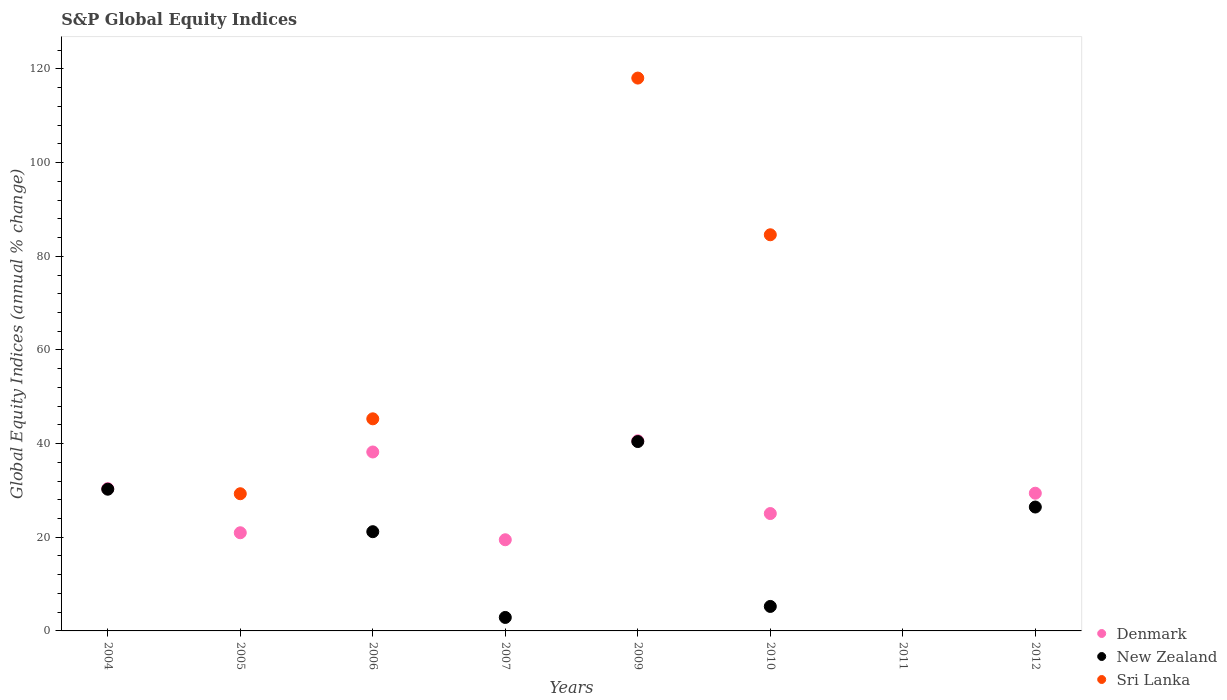How many different coloured dotlines are there?
Make the answer very short. 3. Is the number of dotlines equal to the number of legend labels?
Make the answer very short. No. What is the global equity indices in Sri Lanka in 2007?
Make the answer very short. 0. Across all years, what is the maximum global equity indices in Sri Lanka?
Provide a short and direct response. 118.05. Across all years, what is the minimum global equity indices in Sri Lanka?
Give a very brief answer. 0. What is the total global equity indices in Sri Lanka in the graph?
Provide a succinct answer. 277.22. What is the difference between the global equity indices in New Zealand in 2004 and that in 2010?
Make the answer very short. 25.03. What is the difference between the global equity indices in Sri Lanka in 2006 and the global equity indices in New Zealand in 2010?
Make the answer very short. 40.06. What is the average global equity indices in Denmark per year?
Ensure brevity in your answer.  25.51. In the year 2006, what is the difference between the global equity indices in Denmark and global equity indices in Sri Lanka?
Make the answer very short. -7.08. What is the ratio of the global equity indices in New Zealand in 2009 to that in 2010?
Your answer should be compact. 7.73. Is the global equity indices in New Zealand in 2004 less than that in 2012?
Provide a succinct answer. No. What is the difference between the highest and the second highest global equity indices in Denmark?
Your response must be concise. 2.39. What is the difference between the highest and the lowest global equity indices in Sri Lanka?
Offer a very short reply. 118.05. How many dotlines are there?
Keep it short and to the point. 3. How many years are there in the graph?
Keep it short and to the point. 8. What is the difference between two consecutive major ticks on the Y-axis?
Provide a short and direct response. 20. Are the values on the major ticks of Y-axis written in scientific E-notation?
Your response must be concise. No. Does the graph contain any zero values?
Your response must be concise. Yes. Does the graph contain grids?
Give a very brief answer. No. Where does the legend appear in the graph?
Your answer should be compact. Bottom right. What is the title of the graph?
Your answer should be compact. S&P Global Equity Indices. Does "Greece" appear as one of the legend labels in the graph?
Your answer should be very brief. No. What is the label or title of the Y-axis?
Offer a terse response. Global Equity Indices (annual % change). What is the Global Equity Indices (annual % change) of Denmark in 2004?
Ensure brevity in your answer.  30.39. What is the Global Equity Indices (annual % change) in New Zealand in 2004?
Ensure brevity in your answer.  30.26. What is the Global Equity Indices (annual % change) of Denmark in 2005?
Keep it short and to the point. 20.96. What is the Global Equity Indices (annual % change) in Sri Lanka in 2005?
Your answer should be very brief. 29.29. What is the Global Equity Indices (annual % change) in Denmark in 2006?
Offer a terse response. 38.21. What is the Global Equity Indices (annual % change) of New Zealand in 2006?
Provide a succinct answer. 21.19. What is the Global Equity Indices (annual % change) of Sri Lanka in 2006?
Your answer should be compact. 45.29. What is the Global Equity Indices (annual % change) in Denmark in 2007?
Ensure brevity in your answer.  19.47. What is the Global Equity Indices (annual % change) in New Zealand in 2007?
Provide a short and direct response. 2.88. What is the Global Equity Indices (annual % change) of Denmark in 2009?
Give a very brief answer. 40.6. What is the Global Equity Indices (annual % change) of New Zealand in 2009?
Ensure brevity in your answer.  40.44. What is the Global Equity Indices (annual % change) in Sri Lanka in 2009?
Your answer should be compact. 118.05. What is the Global Equity Indices (annual % change) of Denmark in 2010?
Your response must be concise. 25.06. What is the Global Equity Indices (annual % change) of New Zealand in 2010?
Give a very brief answer. 5.23. What is the Global Equity Indices (annual % change) in Sri Lanka in 2010?
Provide a succinct answer. 84.59. What is the Global Equity Indices (annual % change) in Denmark in 2011?
Offer a very short reply. 0. What is the Global Equity Indices (annual % change) of Denmark in 2012?
Provide a succinct answer. 29.4. What is the Global Equity Indices (annual % change) in New Zealand in 2012?
Offer a terse response. 26.46. Across all years, what is the maximum Global Equity Indices (annual % change) of Denmark?
Ensure brevity in your answer.  40.6. Across all years, what is the maximum Global Equity Indices (annual % change) of New Zealand?
Keep it short and to the point. 40.44. Across all years, what is the maximum Global Equity Indices (annual % change) in Sri Lanka?
Keep it short and to the point. 118.05. Across all years, what is the minimum Global Equity Indices (annual % change) in Denmark?
Your response must be concise. 0. Across all years, what is the minimum Global Equity Indices (annual % change) of Sri Lanka?
Keep it short and to the point. 0. What is the total Global Equity Indices (annual % change) in Denmark in the graph?
Offer a terse response. 204.1. What is the total Global Equity Indices (annual % change) of New Zealand in the graph?
Offer a very short reply. 126.45. What is the total Global Equity Indices (annual % change) of Sri Lanka in the graph?
Keep it short and to the point. 277.23. What is the difference between the Global Equity Indices (annual % change) in Denmark in 2004 and that in 2005?
Offer a very short reply. 9.43. What is the difference between the Global Equity Indices (annual % change) of Denmark in 2004 and that in 2006?
Your answer should be compact. -7.82. What is the difference between the Global Equity Indices (annual % change) of New Zealand in 2004 and that in 2006?
Your response must be concise. 9.07. What is the difference between the Global Equity Indices (annual % change) in Denmark in 2004 and that in 2007?
Offer a terse response. 10.92. What is the difference between the Global Equity Indices (annual % change) of New Zealand in 2004 and that in 2007?
Give a very brief answer. 27.38. What is the difference between the Global Equity Indices (annual % change) of Denmark in 2004 and that in 2009?
Keep it short and to the point. -10.21. What is the difference between the Global Equity Indices (annual % change) in New Zealand in 2004 and that in 2009?
Provide a short and direct response. -10.18. What is the difference between the Global Equity Indices (annual % change) in Denmark in 2004 and that in 2010?
Your answer should be very brief. 5.33. What is the difference between the Global Equity Indices (annual % change) in New Zealand in 2004 and that in 2010?
Your answer should be compact. 25.03. What is the difference between the Global Equity Indices (annual % change) in Denmark in 2004 and that in 2012?
Your response must be concise. 0.99. What is the difference between the Global Equity Indices (annual % change) of New Zealand in 2004 and that in 2012?
Keep it short and to the point. 3.81. What is the difference between the Global Equity Indices (annual % change) in Denmark in 2005 and that in 2006?
Your answer should be very brief. -17.25. What is the difference between the Global Equity Indices (annual % change) of Sri Lanka in 2005 and that in 2006?
Make the answer very short. -16. What is the difference between the Global Equity Indices (annual % change) in Denmark in 2005 and that in 2007?
Keep it short and to the point. 1.5. What is the difference between the Global Equity Indices (annual % change) of Denmark in 2005 and that in 2009?
Offer a terse response. -19.64. What is the difference between the Global Equity Indices (annual % change) in Sri Lanka in 2005 and that in 2009?
Offer a very short reply. -88.76. What is the difference between the Global Equity Indices (annual % change) in Denmark in 2005 and that in 2010?
Offer a very short reply. -4.1. What is the difference between the Global Equity Indices (annual % change) of Sri Lanka in 2005 and that in 2010?
Offer a terse response. -55.3. What is the difference between the Global Equity Indices (annual % change) of Denmark in 2005 and that in 2012?
Give a very brief answer. -8.44. What is the difference between the Global Equity Indices (annual % change) in Denmark in 2006 and that in 2007?
Provide a short and direct response. 18.74. What is the difference between the Global Equity Indices (annual % change) of New Zealand in 2006 and that in 2007?
Offer a very short reply. 18.31. What is the difference between the Global Equity Indices (annual % change) in Denmark in 2006 and that in 2009?
Make the answer very short. -2.39. What is the difference between the Global Equity Indices (annual % change) in New Zealand in 2006 and that in 2009?
Provide a short and direct response. -19.25. What is the difference between the Global Equity Indices (annual % change) of Sri Lanka in 2006 and that in 2009?
Your answer should be compact. -72.76. What is the difference between the Global Equity Indices (annual % change) of Denmark in 2006 and that in 2010?
Offer a terse response. 13.15. What is the difference between the Global Equity Indices (annual % change) of New Zealand in 2006 and that in 2010?
Offer a terse response. 15.96. What is the difference between the Global Equity Indices (annual % change) of Sri Lanka in 2006 and that in 2010?
Keep it short and to the point. -39.3. What is the difference between the Global Equity Indices (annual % change) in Denmark in 2006 and that in 2012?
Ensure brevity in your answer.  8.8. What is the difference between the Global Equity Indices (annual % change) in New Zealand in 2006 and that in 2012?
Your answer should be very brief. -5.27. What is the difference between the Global Equity Indices (annual % change) in Denmark in 2007 and that in 2009?
Ensure brevity in your answer.  -21.14. What is the difference between the Global Equity Indices (annual % change) of New Zealand in 2007 and that in 2009?
Make the answer very short. -37.56. What is the difference between the Global Equity Indices (annual % change) of Denmark in 2007 and that in 2010?
Your answer should be very brief. -5.6. What is the difference between the Global Equity Indices (annual % change) in New Zealand in 2007 and that in 2010?
Ensure brevity in your answer.  -2.35. What is the difference between the Global Equity Indices (annual % change) in Denmark in 2007 and that in 2012?
Provide a short and direct response. -9.94. What is the difference between the Global Equity Indices (annual % change) in New Zealand in 2007 and that in 2012?
Your response must be concise. -23.58. What is the difference between the Global Equity Indices (annual % change) in Denmark in 2009 and that in 2010?
Provide a short and direct response. 15.54. What is the difference between the Global Equity Indices (annual % change) in New Zealand in 2009 and that in 2010?
Provide a succinct answer. 35.21. What is the difference between the Global Equity Indices (annual % change) of Sri Lanka in 2009 and that in 2010?
Make the answer very short. 33.46. What is the difference between the Global Equity Indices (annual % change) in Denmark in 2009 and that in 2012?
Make the answer very short. 11.2. What is the difference between the Global Equity Indices (annual % change) of New Zealand in 2009 and that in 2012?
Keep it short and to the point. 13.98. What is the difference between the Global Equity Indices (annual % change) of Denmark in 2010 and that in 2012?
Offer a terse response. -4.34. What is the difference between the Global Equity Indices (annual % change) of New Zealand in 2010 and that in 2012?
Offer a very short reply. -21.23. What is the difference between the Global Equity Indices (annual % change) of Denmark in 2004 and the Global Equity Indices (annual % change) of Sri Lanka in 2005?
Offer a very short reply. 1.1. What is the difference between the Global Equity Indices (annual % change) in New Zealand in 2004 and the Global Equity Indices (annual % change) in Sri Lanka in 2005?
Your answer should be compact. 0.97. What is the difference between the Global Equity Indices (annual % change) of Denmark in 2004 and the Global Equity Indices (annual % change) of New Zealand in 2006?
Offer a very short reply. 9.2. What is the difference between the Global Equity Indices (annual % change) in Denmark in 2004 and the Global Equity Indices (annual % change) in Sri Lanka in 2006?
Make the answer very short. -14.9. What is the difference between the Global Equity Indices (annual % change) in New Zealand in 2004 and the Global Equity Indices (annual % change) in Sri Lanka in 2006?
Provide a succinct answer. -15.03. What is the difference between the Global Equity Indices (annual % change) of Denmark in 2004 and the Global Equity Indices (annual % change) of New Zealand in 2007?
Provide a short and direct response. 27.51. What is the difference between the Global Equity Indices (annual % change) of Denmark in 2004 and the Global Equity Indices (annual % change) of New Zealand in 2009?
Your response must be concise. -10.05. What is the difference between the Global Equity Indices (annual % change) in Denmark in 2004 and the Global Equity Indices (annual % change) in Sri Lanka in 2009?
Offer a very short reply. -87.66. What is the difference between the Global Equity Indices (annual % change) of New Zealand in 2004 and the Global Equity Indices (annual % change) of Sri Lanka in 2009?
Your response must be concise. -87.79. What is the difference between the Global Equity Indices (annual % change) of Denmark in 2004 and the Global Equity Indices (annual % change) of New Zealand in 2010?
Your answer should be very brief. 25.16. What is the difference between the Global Equity Indices (annual % change) of Denmark in 2004 and the Global Equity Indices (annual % change) of Sri Lanka in 2010?
Give a very brief answer. -54.2. What is the difference between the Global Equity Indices (annual % change) of New Zealand in 2004 and the Global Equity Indices (annual % change) of Sri Lanka in 2010?
Your answer should be compact. -54.33. What is the difference between the Global Equity Indices (annual % change) of Denmark in 2004 and the Global Equity Indices (annual % change) of New Zealand in 2012?
Your answer should be very brief. 3.93. What is the difference between the Global Equity Indices (annual % change) of Denmark in 2005 and the Global Equity Indices (annual % change) of New Zealand in 2006?
Your answer should be very brief. -0.23. What is the difference between the Global Equity Indices (annual % change) in Denmark in 2005 and the Global Equity Indices (annual % change) in Sri Lanka in 2006?
Ensure brevity in your answer.  -24.33. What is the difference between the Global Equity Indices (annual % change) in Denmark in 2005 and the Global Equity Indices (annual % change) in New Zealand in 2007?
Your response must be concise. 18.08. What is the difference between the Global Equity Indices (annual % change) of Denmark in 2005 and the Global Equity Indices (annual % change) of New Zealand in 2009?
Offer a very short reply. -19.47. What is the difference between the Global Equity Indices (annual % change) in Denmark in 2005 and the Global Equity Indices (annual % change) in Sri Lanka in 2009?
Offer a terse response. -97.09. What is the difference between the Global Equity Indices (annual % change) in Denmark in 2005 and the Global Equity Indices (annual % change) in New Zealand in 2010?
Offer a terse response. 15.73. What is the difference between the Global Equity Indices (annual % change) in Denmark in 2005 and the Global Equity Indices (annual % change) in Sri Lanka in 2010?
Provide a short and direct response. -63.63. What is the difference between the Global Equity Indices (annual % change) in Denmark in 2005 and the Global Equity Indices (annual % change) in New Zealand in 2012?
Your response must be concise. -5.49. What is the difference between the Global Equity Indices (annual % change) in Denmark in 2006 and the Global Equity Indices (annual % change) in New Zealand in 2007?
Your answer should be compact. 35.33. What is the difference between the Global Equity Indices (annual % change) of Denmark in 2006 and the Global Equity Indices (annual % change) of New Zealand in 2009?
Your response must be concise. -2.23. What is the difference between the Global Equity Indices (annual % change) of Denmark in 2006 and the Global Equity Indices (annual % change) of Sri Lanka in 2009?
Provide a succinct answer. -79.84. What is the difference between the Global Equity Indices (annual % change) of New Zealand in 2006 and the Global Equity Indices (annual % change) of Sri Lanka in 2009?
Offer a terse response. -96.86. What is the difference between the Global Equity Indices (annual % change) in Denmark in 2006 and the Global Equity Indices (annual % change) in New Zealand in 2010?
Your response must be concise. 32.98. What is the difference between the Global Equity Indices (annual % change) in Denmark in 2006 and the Global Equity Indices (annual % change) in Sri Lanka in 2010?
Offer a very short reply. -46.38. What is the difference between the Global Equity Indices (annual % change) in New Zealand in 2006 and the Global Equity Indices (annual % change) in Sri Lanka in 2010?
Offer a very short reply. -63.4. What is the difference between the Global Equity Indices (annual % change) of Denmark in 2006 and the Global Equity Indices (annual % change) of New Zealand in 2012?
Provide a short and direct response. 11.75. What is the difference between the Global Equity Indices (annual % change) of Denmark in 2007 and the Global Equity Indices (annual % change) of New Zealand in 2009?
Keep it short and to the point. -20.97. What is the difference between the Global Equity Indices (annual % change) of Denmark in 2007 and the Global Equity Indices (annual % change) of Sri Lanka in 2009?
Your answer should be very brief. -98.58. What is the difference between the Global Equity Indices (annual % change) in New Zealand in 2007 and the Global Equity Indices (annual % change) in Sri Lanka in 2009?
Offer a terse response. -115.17. What is the difference between the Global Equity Indices (annual % change) in Denmark in 2007 and the Global Equity Indices (annual % change) in New Zealand in 2010?
Your answer should be very brief. 14.24. What is the difference between the Global Equity Indices (annual % change) of Denmark in 2007 and the Global Equity Indices (annual % change) of Sri Lanka in 2010?
Your answer should be very brief. -65.12. What is the difference between the Global Equity Indices (annual % change) in New Zealand in 2007 and the Global Equity Indices (annual % change) in Sri Lanka in 2010?
Your answer should be very brief. -81.71. What is the difference between the Global Equity Indices (annual % change) in Denmark in 2007 and the Global Equity Indices (annual % change) in New Zealand in 2012?
Give a very brief answer. -6.99. What is the difference between the Global Equity Indices (annual % change) of Denmark in 2009 and the Global Equity Indices (annual % change) of New Zealand in 2010?
Offer a very short reply. 35.37. What is the difference between the Global Equity Indices (annual % change) in Denmark in 2009 and the Global Equity Indices (annual % change) in Sri Lanka in 2010?
Ensure brevity in your answer.  -43.99. What is the difference between the Global Equity Indices (annual % change) of New Zealand in 2009 and the Global Equity Indices (annual % change) of Sri Lanka in 2010?
Keep it short and to the point. -44.15. What is the difference between the Global Equity Indices (annual % change) in Denmark in 2009 and the Global Equity Indices (annual % change) in New Zealand in 2012?
Offer a terse response. 14.15. What is the difference between the Global Equity Indices (annual % change) of Denmark in 2010 and the Global Equity Indices (annual % change) of New Zealand in 2012?
Ensure brevity in your answer.  -1.39. What is the average Global Equity Indices (annual % change) in Denmark per year?
Provide a short and direct response. 25.51. What is the average Global Equity Indices (annual % change) of New Zealand per year?
Ensure brevity in your answer.  15.81. What is the average Global Equity Indices (annual % change) in Sri Lanka per year?
Your response must be concise. 34.65. In the year 2004, what is the difference between the Global Equity Indices (annual % change) in Denmark and Global Equity Indices (annual % change) in New Zealand?
Offer a very short reply. 0.13. In the year 2005, what is the difference between the Global Equity Indices (annual % change) of Denmark and Global Equity Indices (annual % change) of Sri Lanka?
Ensure brevity in your answer.  -8.33. In the year 2006, what is the difference between the Global Equity Indices (annual % change) in Denmark and Global Equity Indices (annual % change) in New Zealand?
Offer a terse response. 17.02. In the year 2006, what is the difference between the Global Equity Indices (annual % change) of Denmark and Global Equity Indices (annual % change) of Sri Lanka?
Make the answer very short. -7.08. In the year 2006, what is the difference between the Global Equity Indices (annual % change) of New Zealand and Global Equity Indices (annual % change) of Sri Lanka?
Offer a very short reply. -24.1. In the year 2007, what is the difference between the Global Equity Indices (annual % change) in Denmark and Global Equity Indices (annual % change) in New Zealand?
Give a very brief answer. 16.59. In the year 2009, what is the difference between the Global Equity Indices (annual % change) in Denmark and Global Equity Indices (annual % change) in New Zealand?
Ensure brevity in your answer.  0.17. In the year 2009, what is the difference between the Global Equity Indices (annual % change) of Denmark and Global Equity Indices (annual % change) of Sri Lanka?
Provide a succinct answer. -77.45. In the year 2009, what is the difference between the Global Equity Indices (annual % change) of New Zealand and Global Equity Indices (annual % change) of Sri Lanka?
Give a very brief answer. -77.61. In the year 2010, what is the difference between the Global Equity Indices (annual % change) in Denmark and Global Equity Indices (annual % change) in New Zealand?
Offer a very short reply. 19.83. In the year 2010, what is the difference between the Global Equity Indices (annual % change) of Denmark and Global Equity Indices (annual % change) of Sri Lanka?
Keep it short and to the point. -59.53. In the year 2010, what is the difference between the Global Equity Indices (annual % change) in New Zealand and Global Equity Indices (annual % change) in Sri Lanka?
Your answer should be compact. -79.36. In the year 2012, what is the difference between the Global Equity Indices (annual % change) of Denmark and Global Equity Indices (annual % change) of New Zealand?
Your answer should be very brief. 2.95. What is the ratio of the Global Equity Indices (annual % change) of Denmark in 2004 to that in 2005?
Give a very brief answer. 1.45. What is the ratio of the Global Equity Indices (annual % change) in Denmark in 2004 to that in 2006?
Provide a succinct answer. 0.8. What is the ratio of the Global Equity Indices (annual % change) of New Zealand in 2004 to that in 2006?
Your answer should be compact. 1.43. What is the ratio of the Global Equity Indices (annual % change) in Denmark in 2004 to that in 2007?
Your response must be concise. 1.56. What is the ratio of the Global Equity Indices (annual % change) of New Zealand in 2004 to that in 2007?
Your response must be concise. 10.51. What is the ratio of the Global Equity Indices (annual % change) of Denmark in 2004 to that in 2009?
Make the answer very short. 0.75. What is the ratio of the Global Equity Indices (annual % change) in New Zealand in 2004 to that in 2009?
Keep it short and to the point. 0.75. What is the ratio of the Global Equity Indices (annual % change) of Denmark in 2004 to that in 2010?
Ensure brevity in your answer.  1.21. What is the ratio of the Global Equity Indices (annual % change) in New Zealand in 2004 to that in 2010?
Provide a short and direct response. 5.79. What is the ratio of the Global Equity Indices (annual % change) in Denmark in 2004 to that in 2012?
Keep it short and to the point. 1.03. What is the ratio of the Global Equity Indices (annual % change) in New Zealand in 2004 to that in 2012?
Offer a very short reply. 1.14. What is the ratio of the Global Equity Indices (annual % change) in Denmark in 2005 to that in 2006?
Your answer should be compact. 0.55. What is the ratio of the Global Equity Indices (annual % change) in Sri Lanka in 2005 to that in 2006?
Offer a very short reply. 0.65. What is the ratio of the Global Equity Indices (annual % change) of Denmark in 2005 to that in 2009?
Make the answer very short. 0.52. What is the ratio of the Global Equity Indices (annual % change) in Sri Lanka in 2005 to that in 2009?
Provide a succinct answer. 0.25. What is the ratio of the Global Equity Indices (annual % change) in Denmark in 2005 to that in 2010?
Your answer should be compact. 0.84. What is the ratio of the Global Equity Indices (annual % change) of Sri Lanka in 2005 to that in 2010?
Your answer should be very brief. 0.35. What is the ratio of the Global Equity Indices (annual % change) of Denmark in 2005 to that in 2012?
Your answer should be very brief. 0.71. What is the ratio of the Global Equity Indices (annual % change) of Denmark in 2006 to that in 2007?
Your answer should be compact. 1.96. What is the ratio of the Global Equity Indices (annual % change) in New Zealand in 2006 to that in 2007?
Make the answer very short. 7.36. What is the ratio of the Global Equity Indices (annual % change) in Denmark in 2006 to that in 2009?
Keep it short and to the point. 0.94. What is the ratio of the Global Equity Indices (annual % change) of New Zealand in 2006 to that in 2009?
Your answer should be compact. 0.52. What is the ratio of the Global Equity Indices (annual % change) of Sri Lanka in 2006 to that in 2009?
Keep it short and to the point. 0.38. What is the ratio of the Global Equity Indices (annual % change) in Denmark in 2006 to that in 2010?
Offer a very short reply. 1.52. What is the ratio of the Global Equity Indices (annual % change) of New Zealand in 2006 to that in 2010?
Offer a terse response. 4.05. What is the ratio of the Global Equity Indices (annual % change) in Sri Lanka in 2006 to that in 2010?
Provide a short and direct response. 0.54. What is the ratio of the Global Equity Indices (annual % change) of Denmark in 2006 to that in 2012?
Your answer should be very brief. 1.3. What is the ratio of the Global Equity Indices (annual % change) in New Zealand in 2006 to that in 2012?
Your answer should be compact. 0.8. What is the ratio of the Global Equity Indices (annual % change) of Denmark in 2007 to that in 2009?
Provide a short and direct response. 0.48. What is the ratio of the Global Equity Indices (annual % change) of New Zealand in 2007 to that in 2009?
Make the answer very short. 0.07. What is the ratio of the Global Equity Indices (annual % change) in Denmark in 2007 to that in 2010?
Give a very brief answer. 0.78. What is the ratio of the Global Equity Indices (annual % change) of New Zealand in 2007 to that in 2010?
Make the answer very short. 0.55. What is the ratio of the Global Equity Indices (annual % change) of Denmark in 2007 to that in 2012?
Your answer should be very brief. 0.66. What is the ratio of the Global Equity Indices (annual % change) in New Zealand in 2007 to that in 2012?
Keep it short and to the point. 0.11. What is the ratio of the Global Equity Indices (annual % change) in Denmark in 2009 to that in 2010?
Offer a terse response. 1.62. What is the ratio of the Global Equity Indices (annual % change) of New Zealand in 2009 to that in 2010?
Offer a terse response. 7.73. What is the ratio of the Global Equity Indices (annual % change) in Sri Lanka in 2009 to that in 2010?
Give a very brief answer. 1.4. What is the ratio of the Global Equity Indices (annual % change) of Denmark in 2009 to that in 2012?
Your answer should be very brief. 1.38. What is the ratio of the Global Equity Indices (annual % change) of New Zealand in 2009 to that in 2012?
Your answer should be compact. 1.53. What is the ratio of the Global Equity Indices (annual % change) of Denmark in 2010 to that in 2012?
Offer a very short reply. 0.85. What is the ratio of the Global Equity Indices (annual % change) of New Zealand in 2010 to that in 2012?
Keep it short and to the point. 0.2. What is the difference between the highest and the second highest Global Equity Indices (annual % change) in Denmark?
Provide a short and direct response. 2.39. What is the difference between the highest and the second highest Global Equity Indices (annual % change) in New Zealand?
Your answer should be very brief. 10.18. What is the difference between the highest and the second highest Global Equity Indices (annual % change) of Sri Lanka?
Offer a terse response. 33.46. What is the difference between the highest and the lowest Global Equity Indices (annual % change) of Denmark?
Your answer should be very brief. 40.6. What is the difference between the highest and the lowest Global Equity Indices (annual % change) in New Zealand?
Make the answer very short. 40.44. What is the difference between the highest and the lowest Global Equity Indices (annual % change) in Sri Lanka?
Make the answer very short. 118.05. 